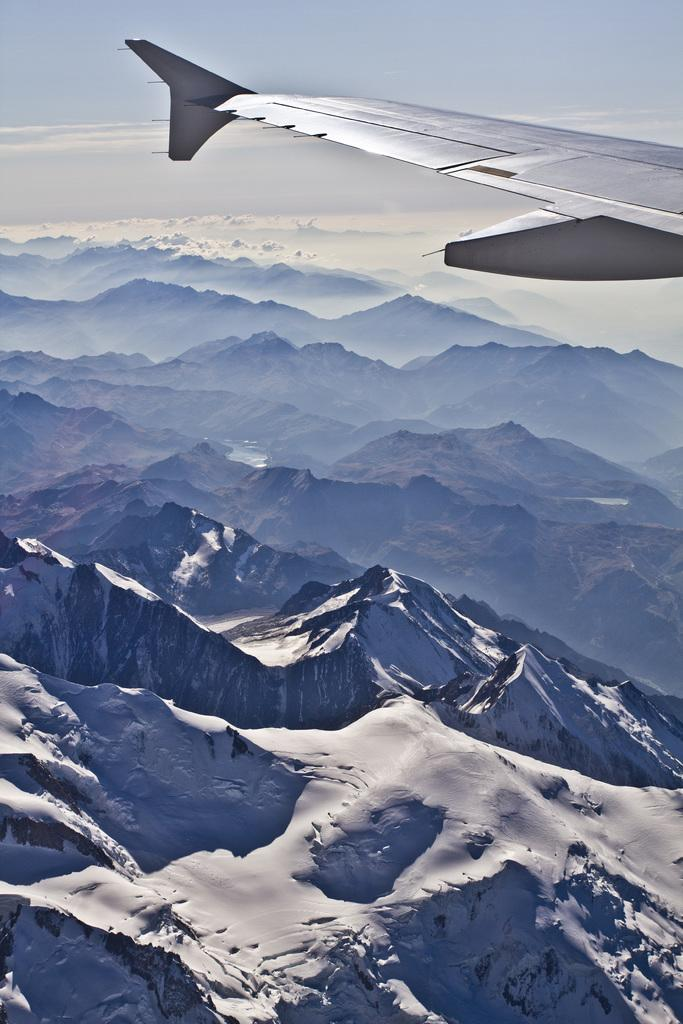What is the main subject of the image? The main subject of the image is an aircraft. Where is the aircraft located in the image? The aircraft is in the air. What can be seen in the background of the image? There are mountains and the sky visible in the background of the image. What is the condition of the mountains in the image? The mountains are covered with snow. What type of trail can be seen behind the aircraft in the image? There is no trail visible behind the aircraft in the image. What kind of structure is present on the mountains in the image? There are no structures visible on the mountains in the image; they are covered with snow. 